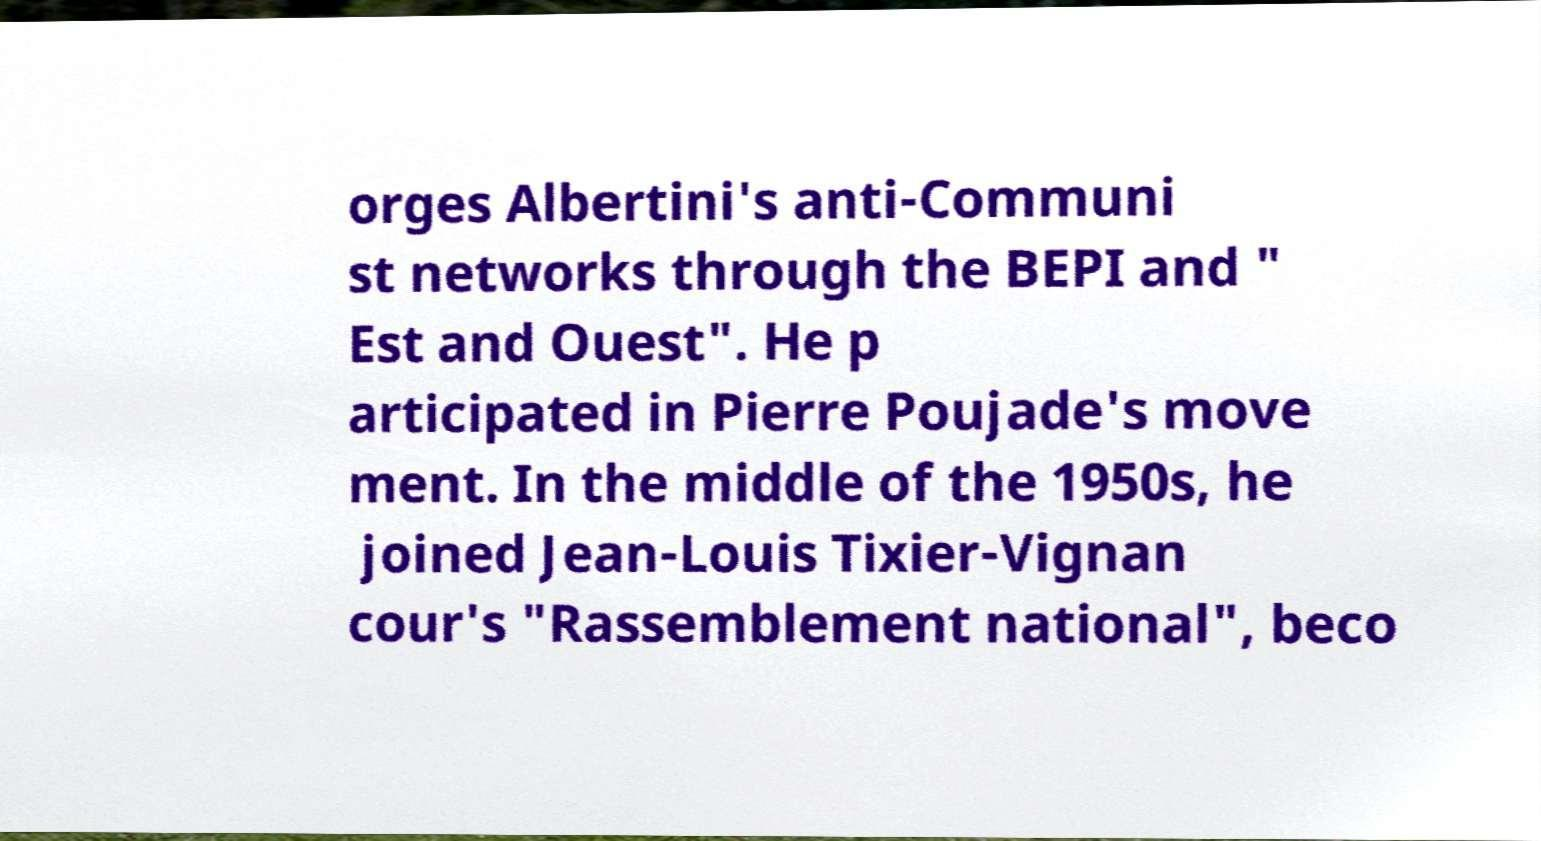What messages or text are displayed in this image? I need them in a readable, typed format. orges Albertini's anti-Communi st networks through the BEPI and " Est and Ouest". He p articipated in Pierre Poujade's move ment. In the middle of the 1950s, he joined Jean-Louis Tixier-Vignan cour's "Rassemblement national", beco 